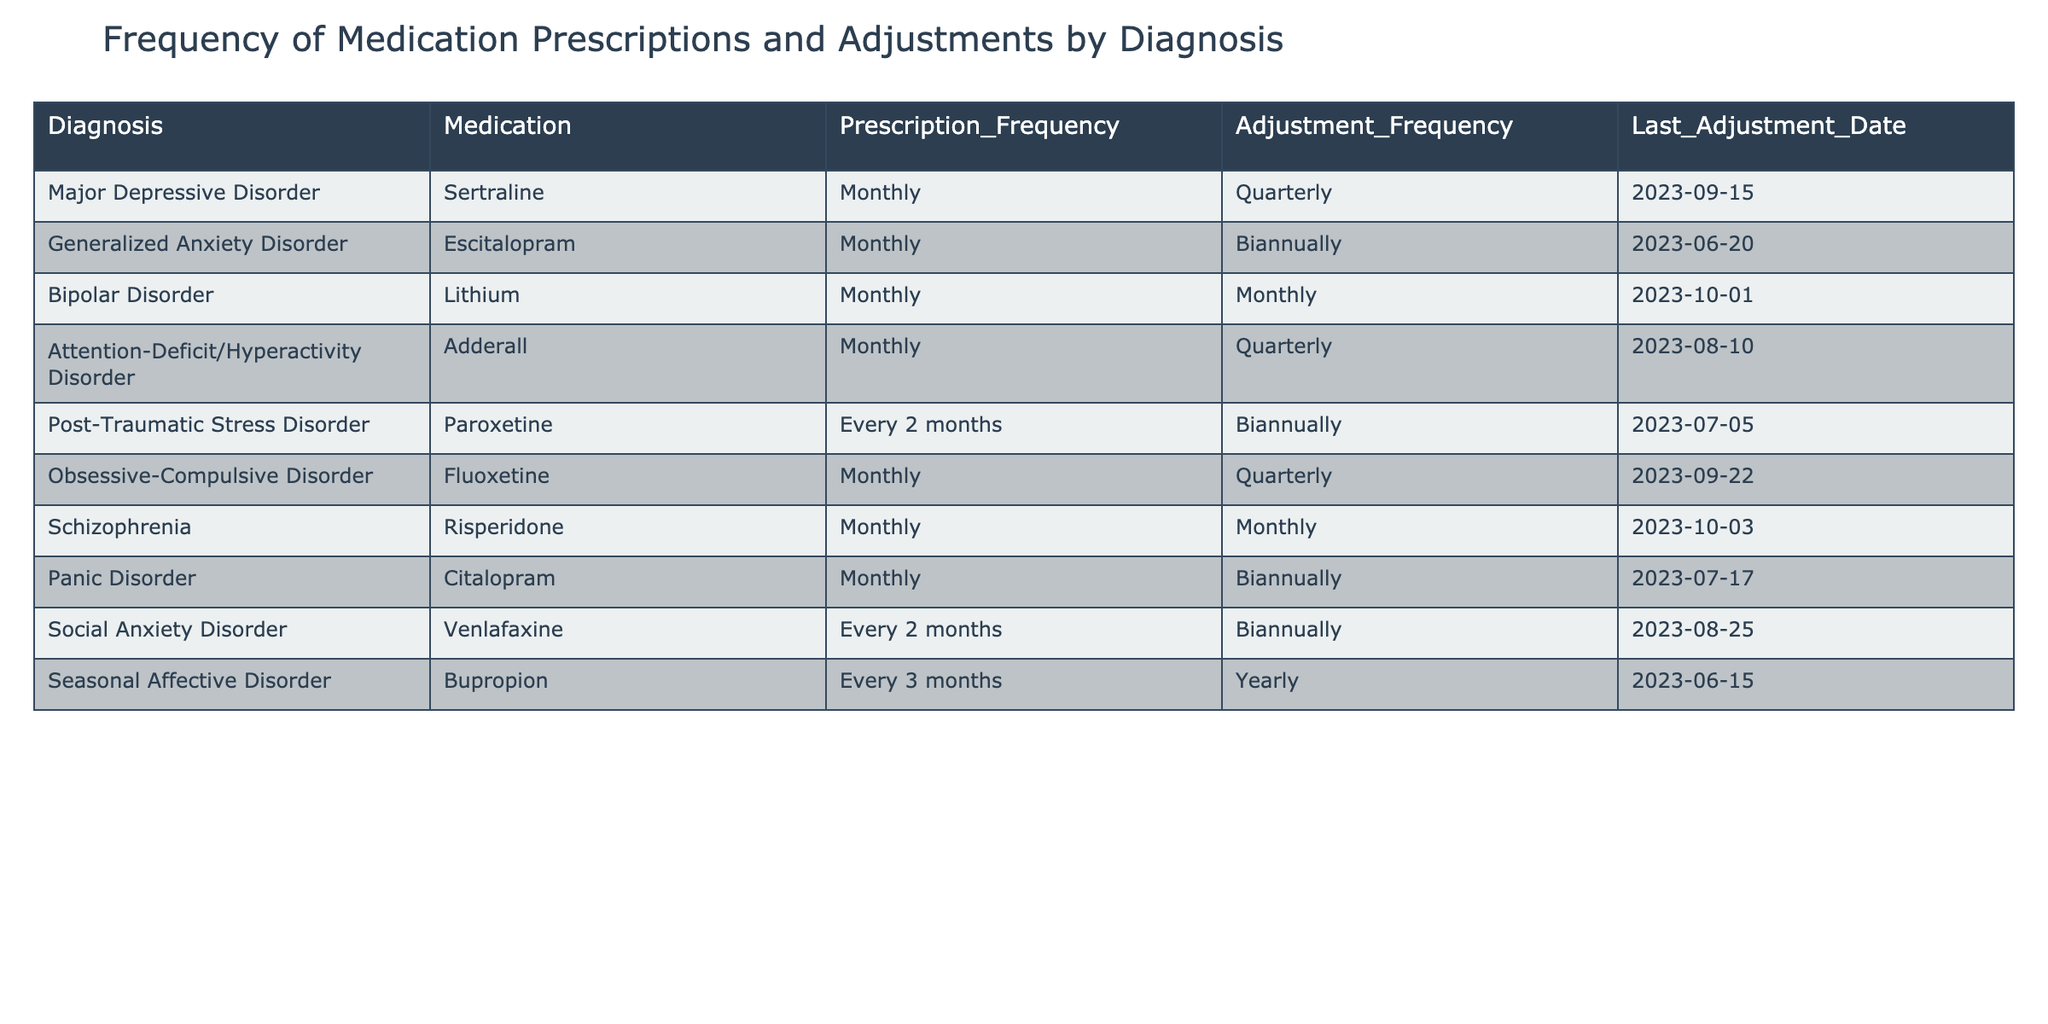What is the prescription frequency for Major Depressive Disorder? Referring to the table, the prescription frequency for Major Depressive Disorder is listed as "Monthly".
Answer: Monthly How many medications have a quarterly adjustment frequency? By examining the table, there are three medications (Sertraline, Attention-Deficit/Hyperactivity Disorder with Adderall, and Obsessive-Compulsive Disorder with Fluoxetine) that have a quarterly adjustment frequency.
Answer: 3 Is Venlafaxine prescribed monthly? Looking at the table, Venlafaxine is prescribed every two months, so it is not prescribed monthly.
Answer: No What is the last adjustment date for the medication used in Bipolar Disorder? The last adjustment date for Lithium, the medication used in Bipolar Disorder, is stated as 2023-10-01.
Answer: 2023-10-01 Which diagnosis has a medication with a yearly adjustment frequency? The table indicates that Seasonal Affective Disorder is the diagnosis with the medication Bupropion that has a yearly adjustment frequency.
Answer: Seasonal Affective Disorder What is the difference in the prescription frequency between medications for Post-Traumatic Stress Disorder and Generalized Anxiety Disorder? Post-Traumatic Stress Disorder has a prescription frequency of every 2 months, while Generalized Anxiety Disorder has a prescription frequency of monthly. Converting "every 2 months" to a monthly frequency gives us a prescription frequency of 0.5 per month. The difference is 1 - 0.5 = 0.5, which indicates that Post-Traumatic Stress Disorder is prescribed less frequently.
Answer: 0.5 Are there any medications which require adjustments more frequently than monthly? By analyzing the table, all medications either have a monthly adjustment frequency or less frequent adjustments. Therefore, no medications require adjustments more frequently than monthly.
Answer: No Which diagnosis medication combination has the most frequent adjustments? From the table, both Bipolar Disorder and Schizophrenia have medications that require monthly adjustments. Therefore, this diagnosis-medication combination indicates the most frequent adjustments.
Answer: Bipolar Disorder and Schizophrenia What is the average prescription frequency for medications prescribed every 2 months? The two medications that are prescribed every 2 months are Venlafaxine and Paroxetine. Their prescription frequency in terms of months is 2 months for each medication. The average is (2 + 2) / 2 = 2 months.
Answer: 2 months 